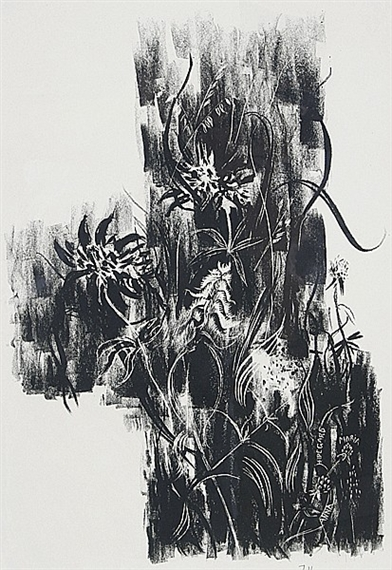How might the technique used in this print contribute to the overall expression of the artwork? The technique used here is likely lithography, which allows for both boldness and subtlety in the prints. This technique can handle a wide range of textural details, from deep blacks to subtle grays, crucial for the emotive quality of abstract expressionism. The ability to create varied textures and line weights contributes significantly to the artwork's expression, suggesting movement and depth that engage viewers' senses and invite them to explore the interplay of forms and the emotions they might evoke. 